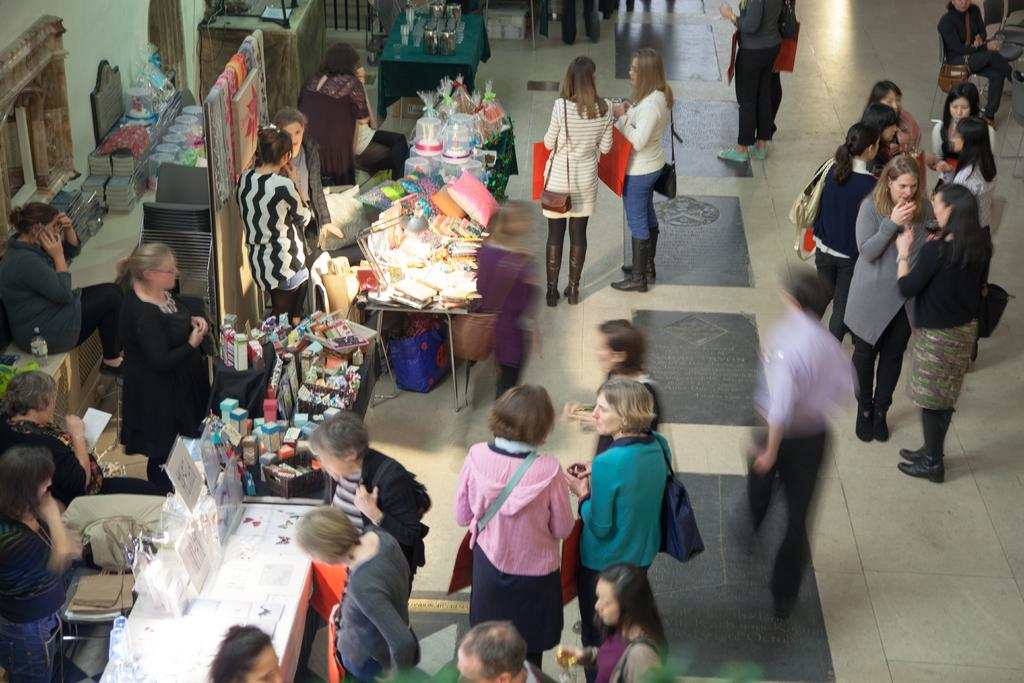What can be seen in the image involving people? There are people standing in the image. What type of structures are present in the image? There are stalls in the image. What type of furniture is visible in the image? There are tables and chairs in the image. What is placed on the tables in the image? There are objects on the tables in the image. Can you see a boat in the image? No, there is no boat present in the image. What type of jam is being served on the tables in the image? There is no jam visible in the image; only objects on the tables are mentioned. 